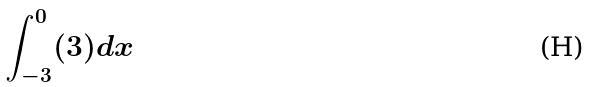<formula> <loc_0><loc_0><loc_500><loc_500>\int _ { - 3 } ^ { 0 } ( 3 ) d x</formula> 